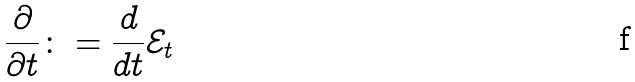Convert formula to latex. <formula><loc_0><loc_0><loc_500><loc_500>\frac { \partial } { \partial t } \colon = \frac { d } { d t } \mathcal { E } _ { t }</formula> 